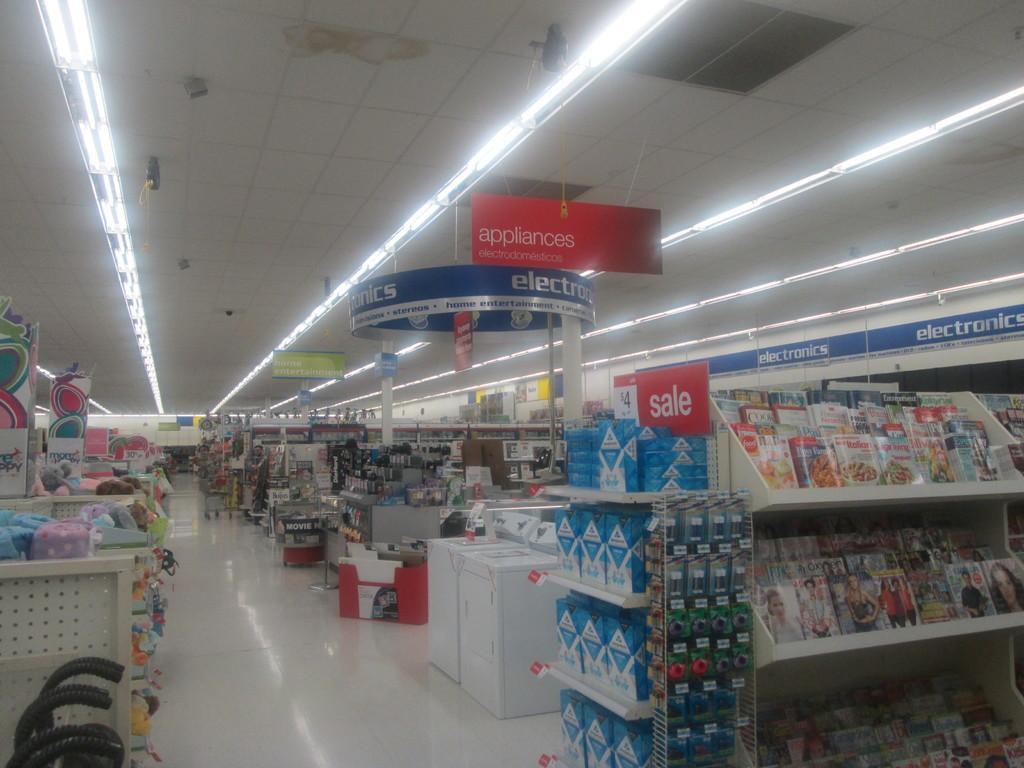<image>
Present a compact description of the photo's key features. A store that sells books, appliances and electronics. 